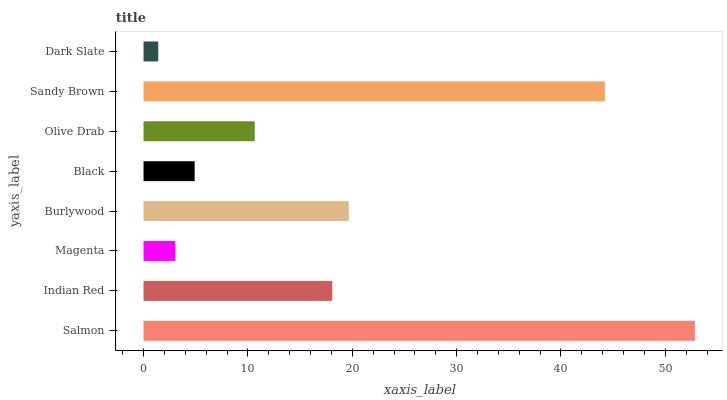Is Dark Slate the minimum?
Answer yes or no. Yes. Is Salmon the maximum?
Answer yes or no. Yes. Is Indian Red the minimum?
Answer yes or no. No. Is Indian Red the maximum?
Answer yes or no. No. Is Salmon greater than Indian Red?
Answer yes or no. Yes. Is Indian Red less than Salmon?
Answer yes or no. Yes. Is Indian Red greater than Salmon?
Answer yes or no. No. Is Salmon less than Indian Red?
Answer yes or no. No. Is Indian Red the high median?
Answer yes or no. Yes. Is Olive Drab the low median?
Answer yes or no. Yes. Is Dark Slate the high median?
Answer yes or no. No. Is Magenta the low median?
Answer yes or no. No. 